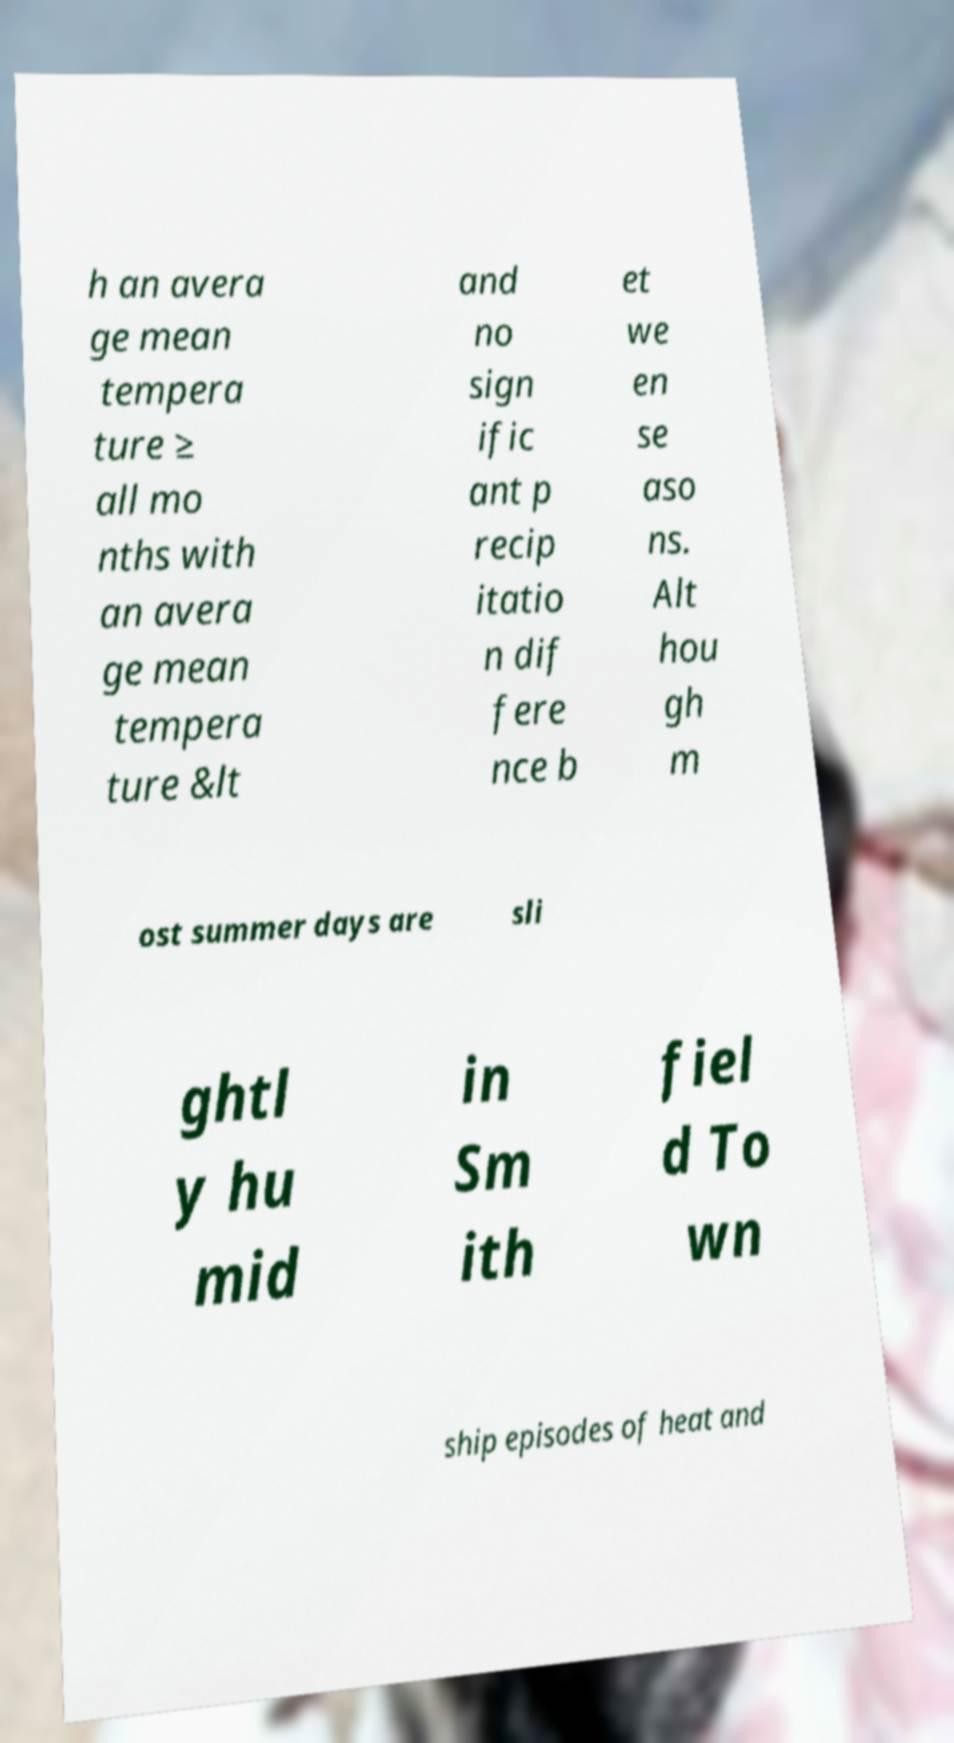What messages or text are displayed in this image? I need them in a readable, typed format. h an avera ge mean tempera ture ≥ all mo nths with an avera ge mean tempera ture &lt and no sign ific ant p recip itatio n dif fere nce b et we en se aso ns. Alt hou gh m ost summer days are sli ghtl y hu mid in Sm ith fiel d To wn ship episodes of heat and 